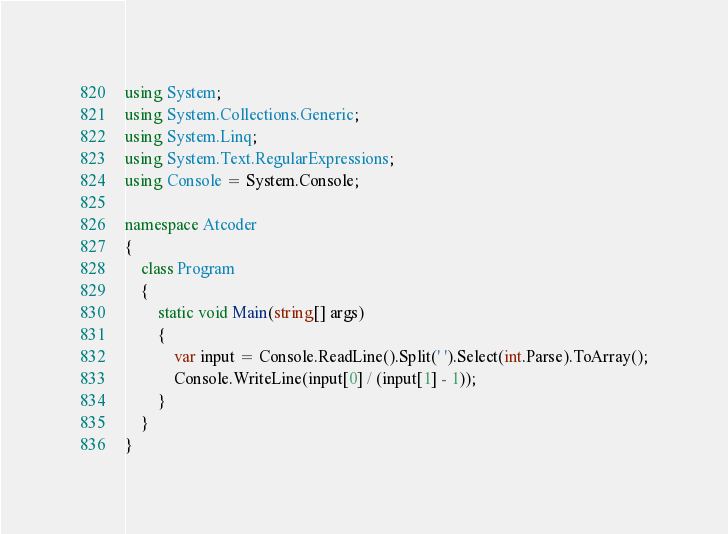Convert code to text. <code><loc_0><loc_0><loc_500><loc_500><_C#_>using System;
using System.Collections.Generic;
using System.Linq;
using System.Text.RegularExpressions;
using Console = System.Console;

namespace Atcoder
{
    class Program
    {
        static void Main(string[] args)
        {
            var input = Console.ReadLine().Split(' ').Select(int.Parse).ToArray();
            Console.WriteLine(input[0] / (input[1] - 1));
        }
    }
}</code> 